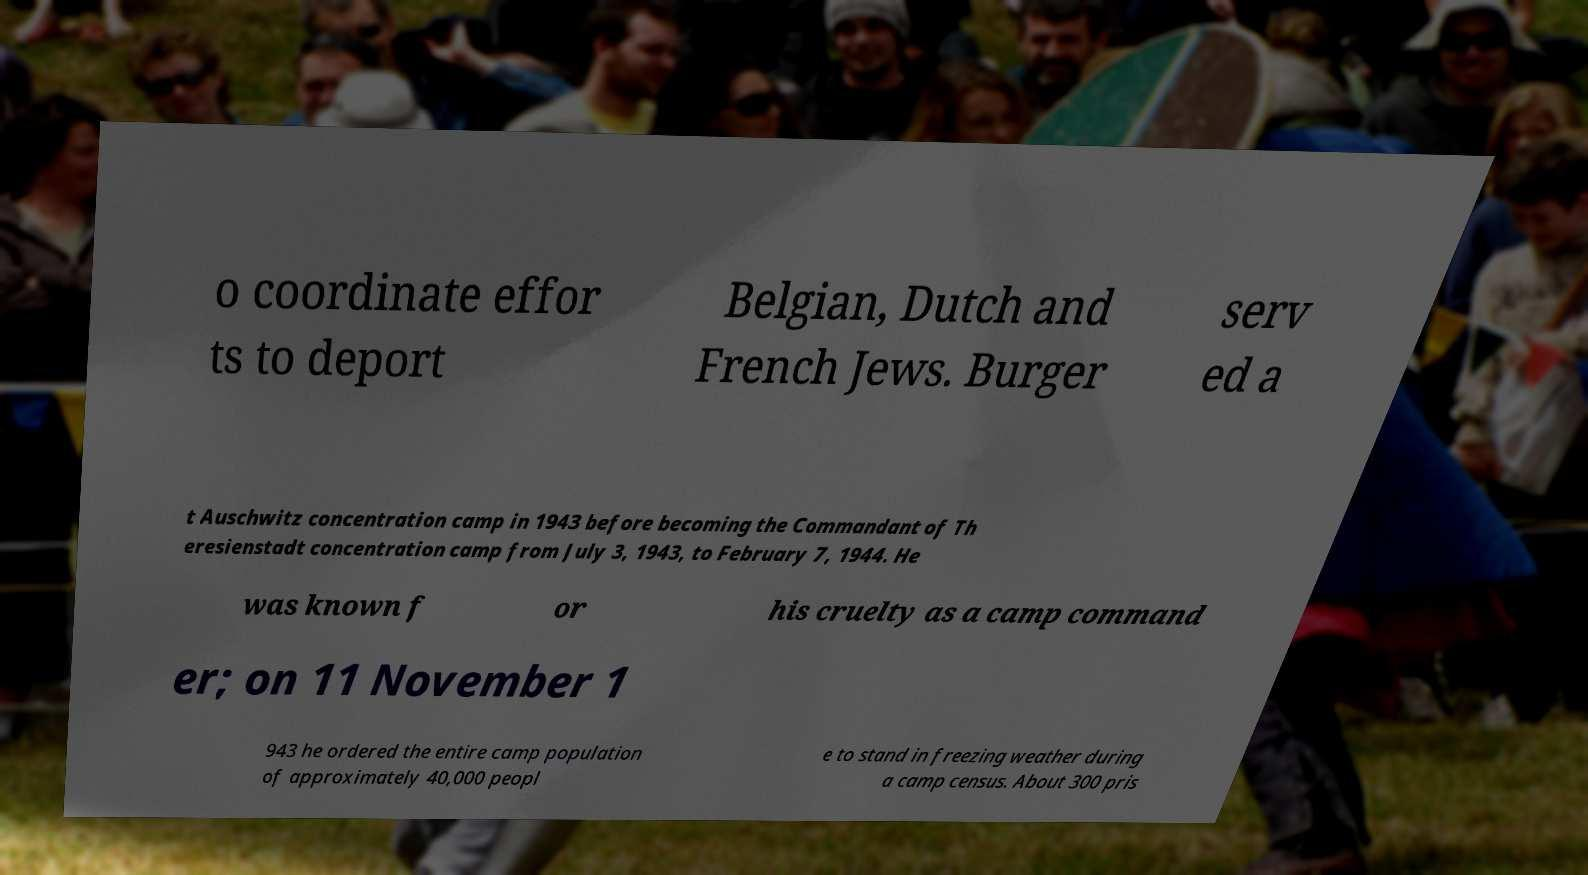For documentation purposes, I need the text within this image transcribed. Could you provide that? o coordinate effor ts to deport Belgian, Dutch and French Jews. Burger serv ed a t Auschwitz concentration camp in 1943 before becoming the Commandant of Th eresienstadt concentration camp from July 3, 1943, to February 7, 1944. He was known f or his cruelty as a camp command er; on 11 November 1 943 he ordered the entire camp population of approximately 40,000 peopl e to stand in freezing weather during a camp census. About 300 pris 